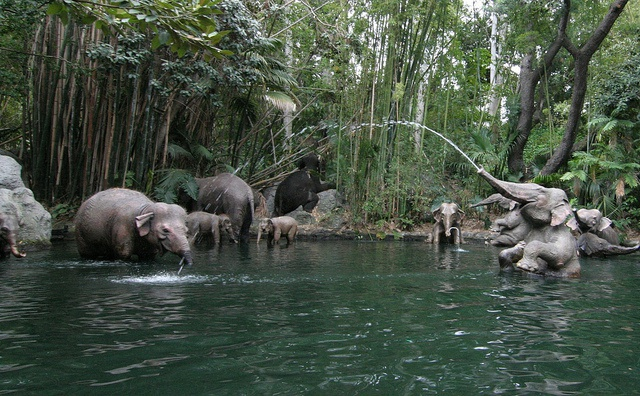Describe the objects in this image and their specific colors. I can see elephant in darkgreen, darkgray, gray, black, and lightgray tones, elephant in darkgreen, black, darkgray, and gray tones, elephant in darkgreen, black, gray, and teal tones, elephant in darkgreen, black, and gray tones, and elephant in darkgreen, gray, darkgray, black, and lightgray tones in this image. 